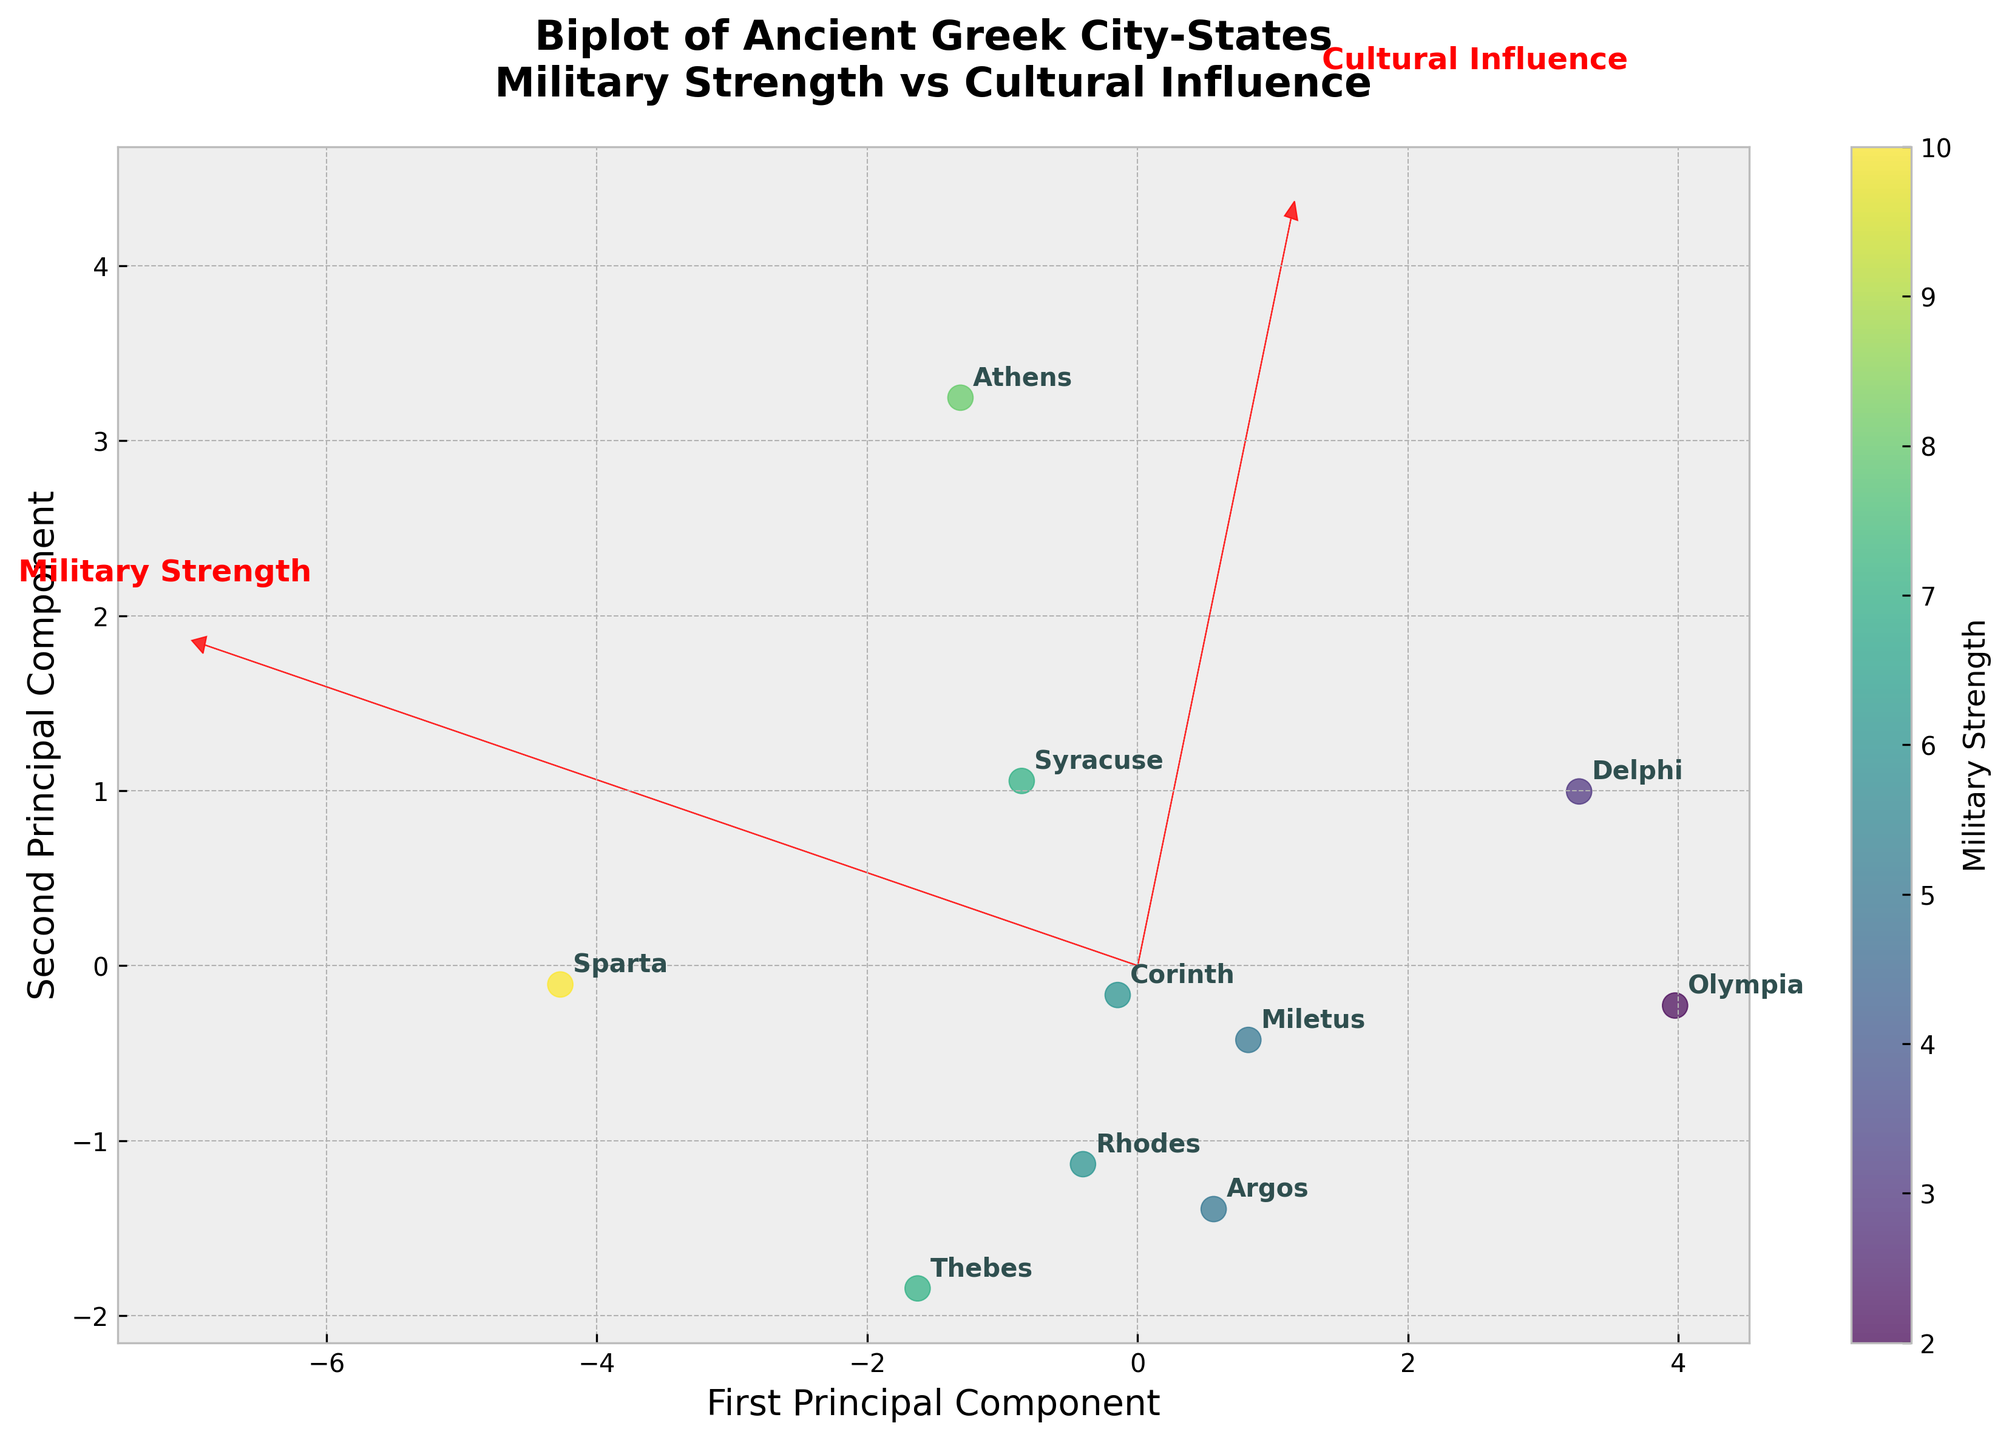How many city-states are represented on the biplot? Count the number of different annotated city-state labels on the plot.
Answer: 10 What is the title of the biplot? Look at the title text located at the top of the biplot.
Answer: Biplot of Ancient Greek City-States Military Strength vs Cultural Influence Which city-state has the highest value for cultural influence? Identify the city-state annotation that is positioned furthest along the positive direction of the "Cultural Influence" axis vector (red arrow).
Answer: Athens Which city-state is approximately at the average of both military strength and cultural influence? Find the city-state near the origin (0,0) in the principal component space since it represents the mean-centered data.
Answer: Rhodes Which city-state shows a strong cultural influence but weak military strength? Find the city-state far in the positive direction of the "Cultural Influence" vector but low in the "Military Strength" vector.
Answer: Delphi How does Sparta compare to Athens in terms of military strength? Look at their respective annotations and check the "Military Strength" values represented by the color intensity; observe the scatter points' color or refer to the original data to confirm.
Answer: Sparta is stronger militarily than Athens Which two city-states have similar positions in terms of military strength and cultural influence? Identify city-states located close to each other in both the first and second principal components on the biplot.
Answer: Corinth and Miletus What do the red arrows represent in the biplot? Refer to the components visually directed by the red arrows and text annotations of "Military Strength" and "Cultural Influence". These vectors indicate the direction of maximum variance.
Answer: Eigenvectors for military strength and cultural influence Which city-state is indicated by the point furthest to the right on the first principal component? Look at the annotated city-state furthest along the positive direction of the first principal component (horizontal axis).
Answer: Sparta What can be inferred about the relationship between military strength and cultural influence from the biplot? Analyze the orientations of the red vectors (eigenvectors). If they point in different directions, it suggests a low or inverse correlation; if similar, a high correlation.
Answer: There is no strong correlation since vectors are distinctly separated 